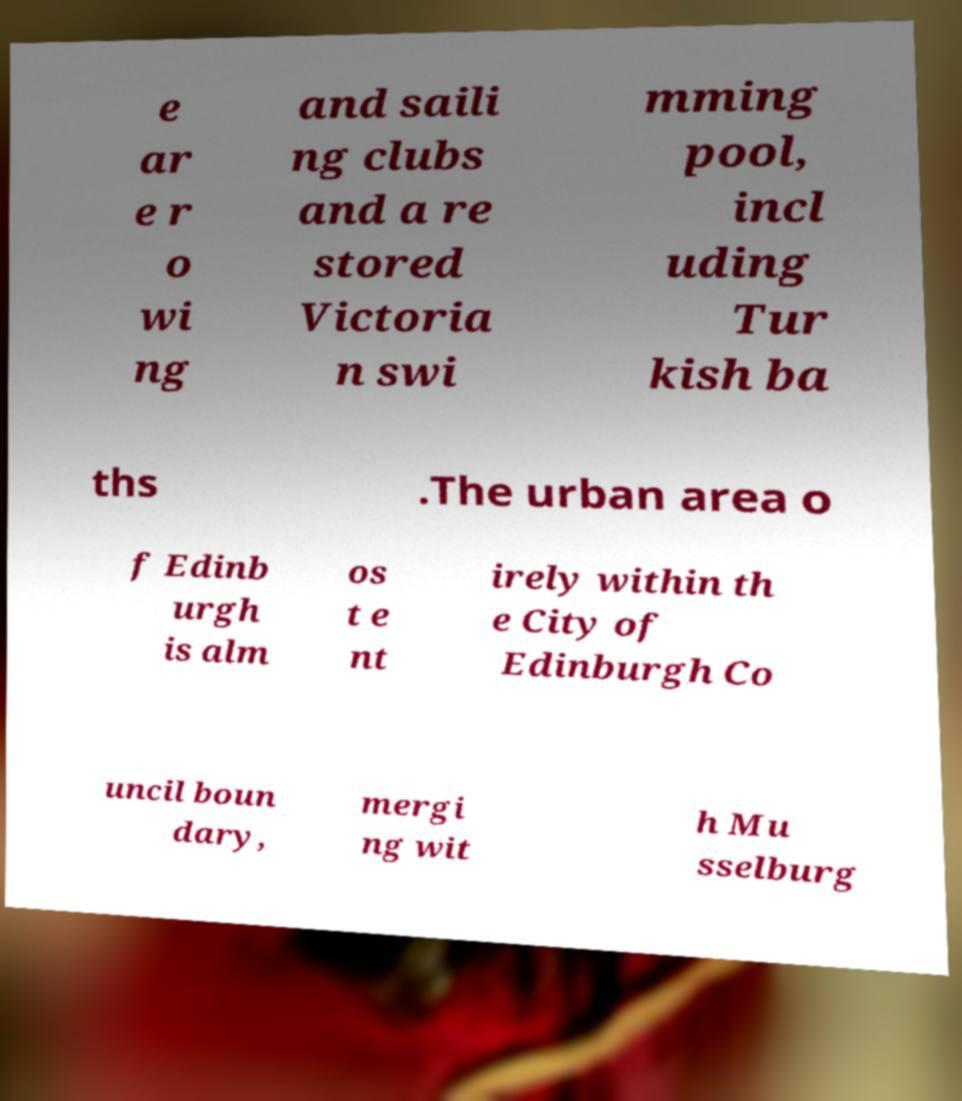For documentation purposes, I need the text within this image transcribed. Could you provide that? e ar e r o wi ng and saili ng clubs and a re stored Victoria n swi mming pool, incl uding Tur kish ba ths .The urban area o f Edinb urgh is alm os t e nt irely within th e City of Edinburgh Co uncil boun dary, mergi ng wit h Mu sselburg 